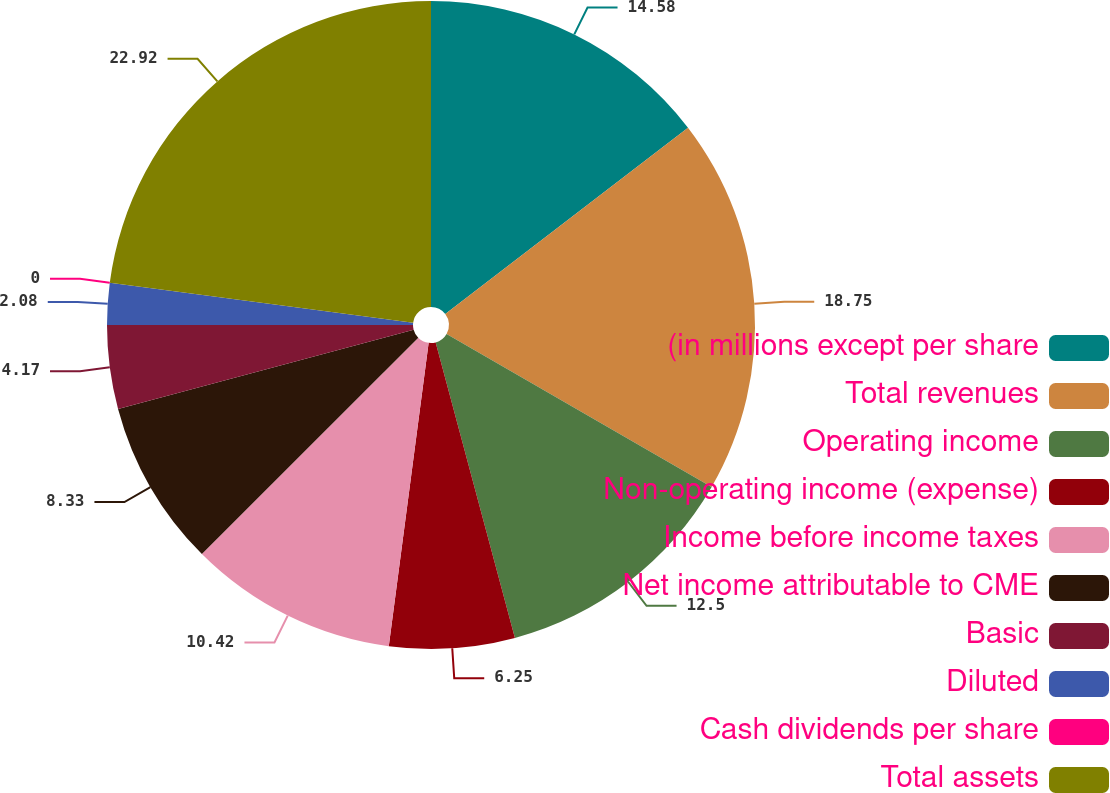Convert chart to OTSL. <chart><loc_0><loc_0><loc_500><loc_500><pie_chart><fcel>(in millions except per share<fcel>Total revenues<fcel>Operating income<fcel>Non-operating income (expense)<fcel>Income before income taxes<fcel>Net income attributable to CME<fcel>Basic<fcel>Diluted<fcel>Cash dividends per share<fcel>Total assets<nl><fcel>14.58%<fcel>18.75%<fcel>12.5%<fcel>6.25%<fcel>10.42%<fcel>8.33%<fcel>4.17%<fcel>2.08%<fcel>0.0%<fcel>22.92%<nl></chart> 